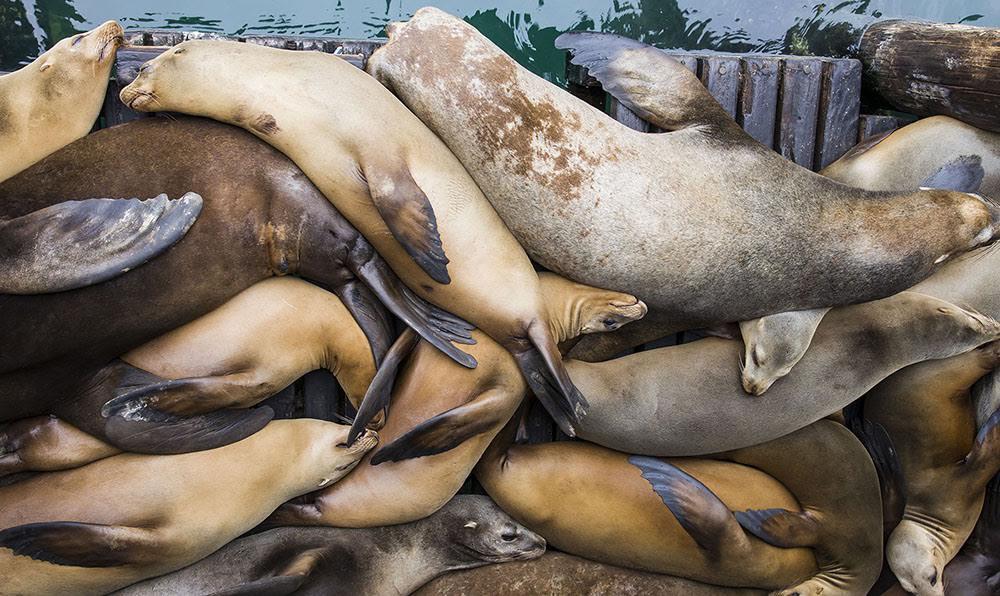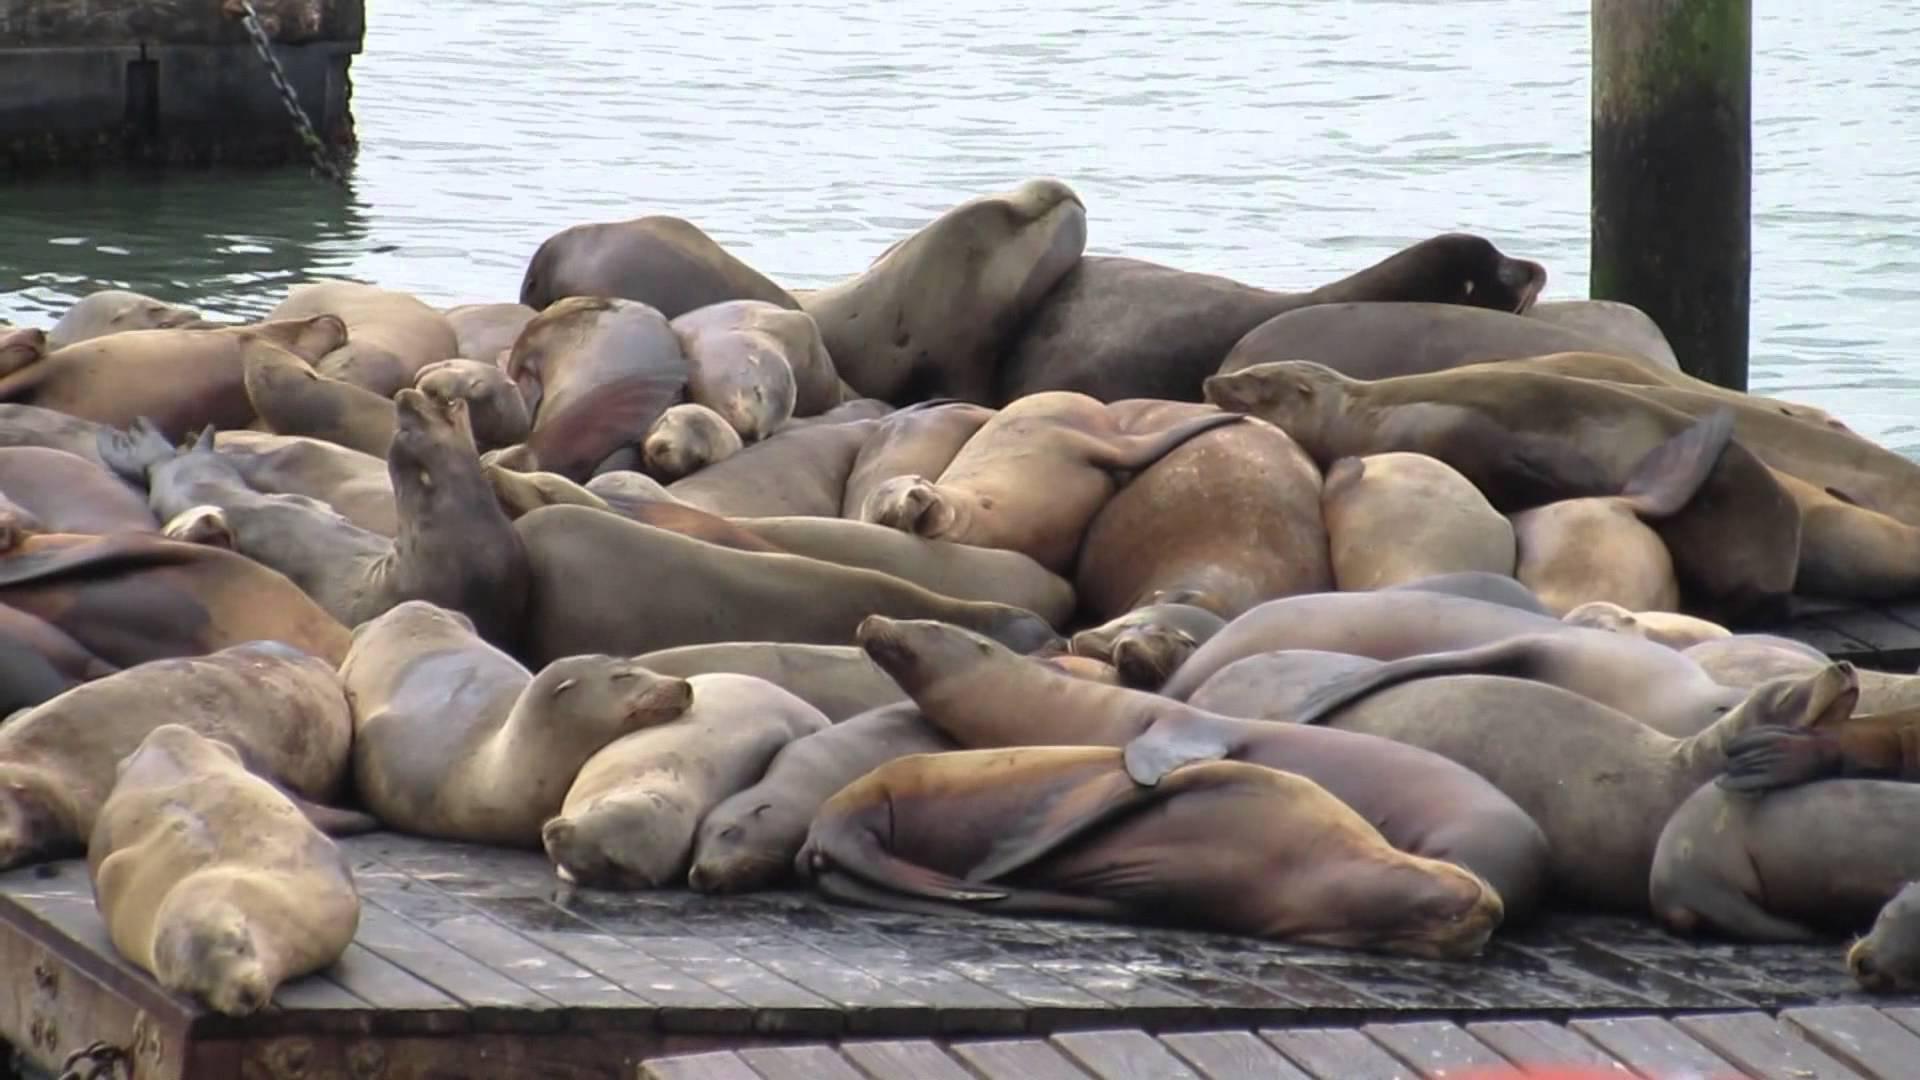The first image is the image on the left, the second image is the image on the right. For the images displayed, is the sentence "There are less than ten sea mammals sunning in the image on the right." factually correct? Answer yes or no. No. The first image is the image on the left, the second image is the image on the right. Analyze the images presented: Is the assertion "An image shows a mass of seals lying on a structure made of wooden planks." valid? Answer yes or no. Yes. 